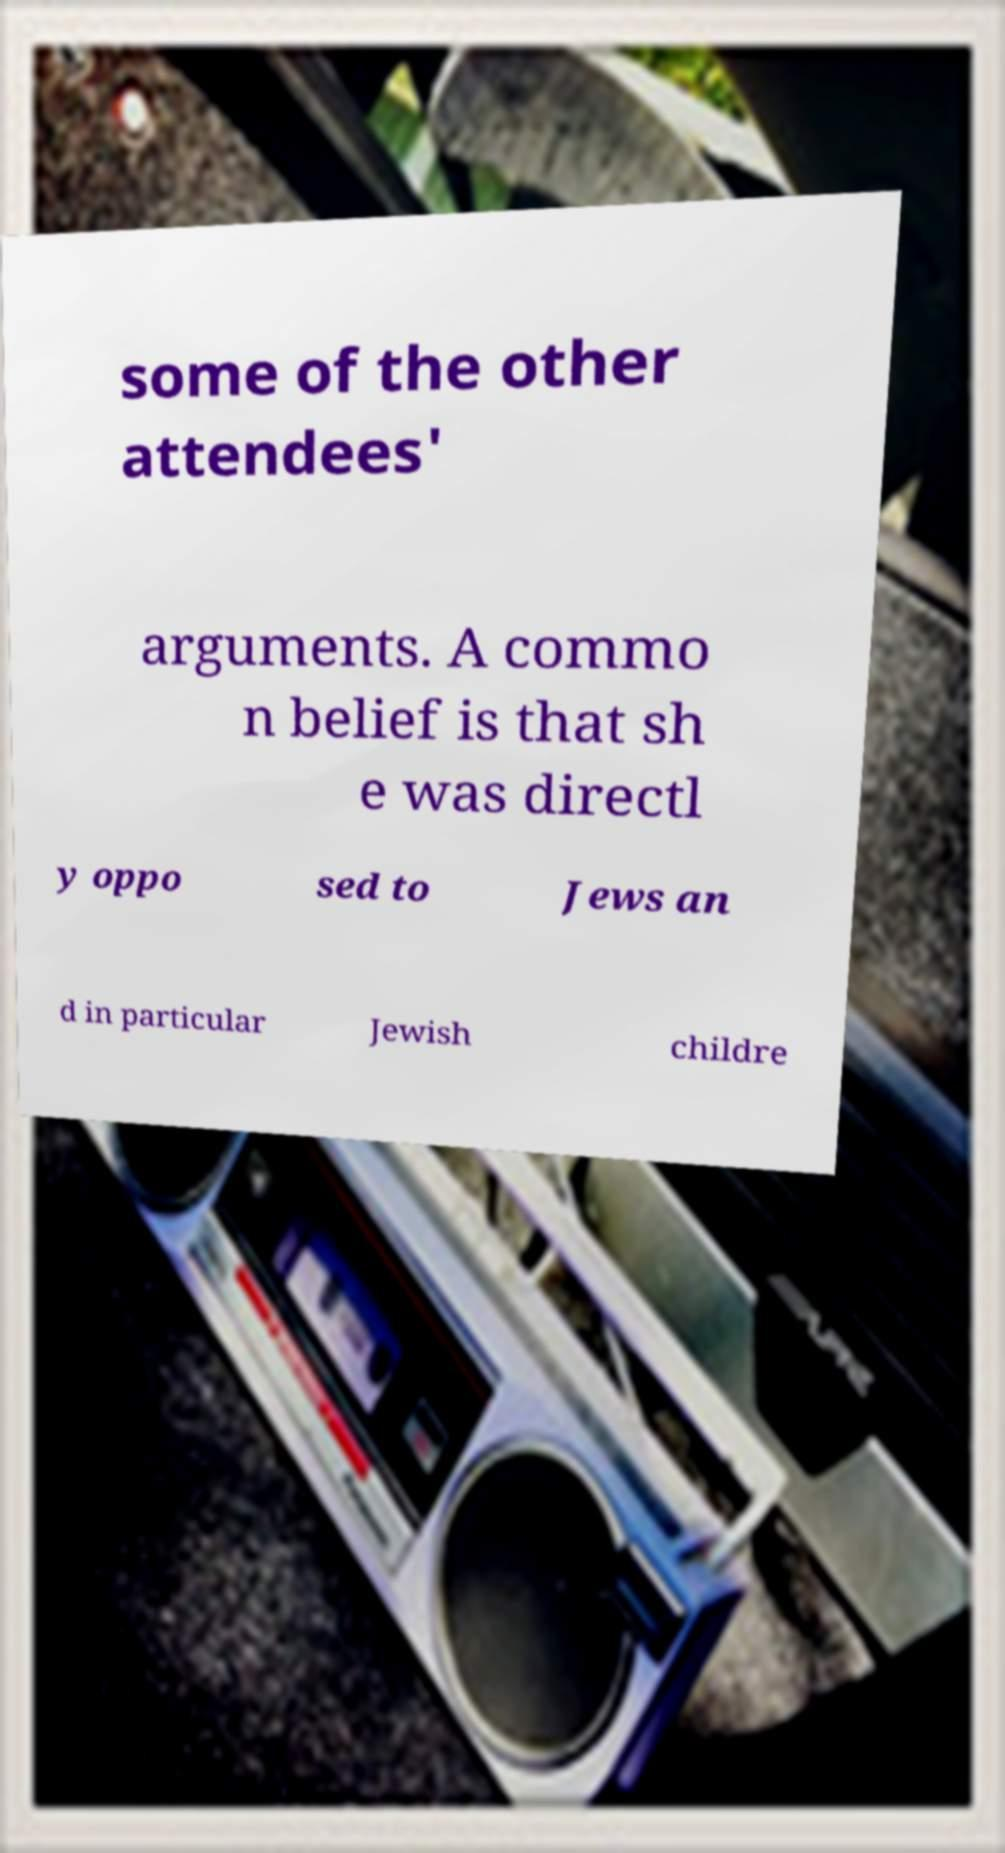Please read and relay the text visible in this image. What does it say? some of the other attendees' arguments. A commo n belief is that sh e was directl y oppo sed to Jews an d in particular Jewish childre 